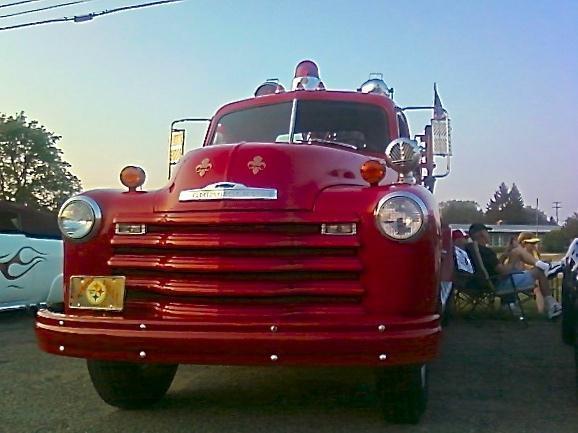What do those riding this vessel use to do their jobs?
Select the accurate answer and provide explanation: 'Answer: answer
Rationale: rationale.'
Options: Air, milk, water, singing. Answer: water.
Rationale: The automobile is a firetruck, used by fireman. 